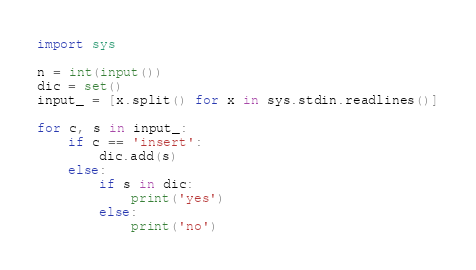<code> <loc_0><loc_0><loc_500><loc_500><_Python_>import sys

n = int(input())
dic = set()
input_ = [x.split() for x in sys.stdin.readlines()]

for c, s in input_:
    if c == 'insert':
        dic.add(s)
    else:
        if s in dic:
            print('yes')
        else:
            print('no')</code> 